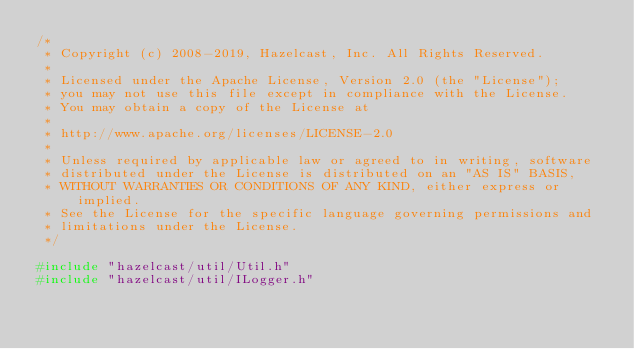Convert code to text. <code><loc_0><loc_0><loc_500><loc_500><_C++_>/*
 * Copyright (c) 2008-2019, Hazelcast, Inc. All Rights Reserved.
 *
 * Licensed under the Apache License, Version 2.0 (the "License");
 * you may not use this file except in compliance with the License.
 * You may obtain a copy of the License at
 *
 * http://www.apache.org/licenses/LICENSE-2.0
 *
 * Unless required by applicable law or agreed to in writing, software
 * distributed under the License is distributed on an "AS IS" BASIS,
 * WITHOUT WARRANTIES OR CONDITIONS OF ANY KIND, either express or implied.
 * See the License for the specific language governing permissions and
 * limitations under the License.
 */

#include "hazelcast/util/Util.h"
#include "hazelcast/util/ILogger.h"
</code> 